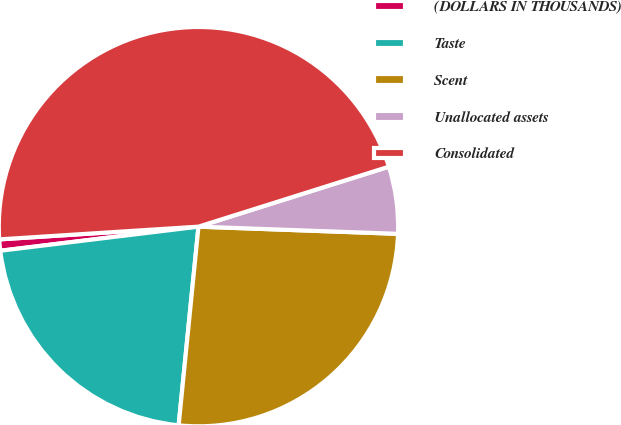Convert chart to OTSL. <chart><loc_0><loc_0><loc_500><loc_500><pie_chart><fcel>(DOLLARS IN THOUSANDS)<fcel>Taste<fcel>Scent<fcel>Unallocated assets<fcel>Consolidated<nl><fcel>0.91%<fcel>21.49%<fcel>26.01%<fcel>5.43%<fcel>46.16%<nl></chart> 